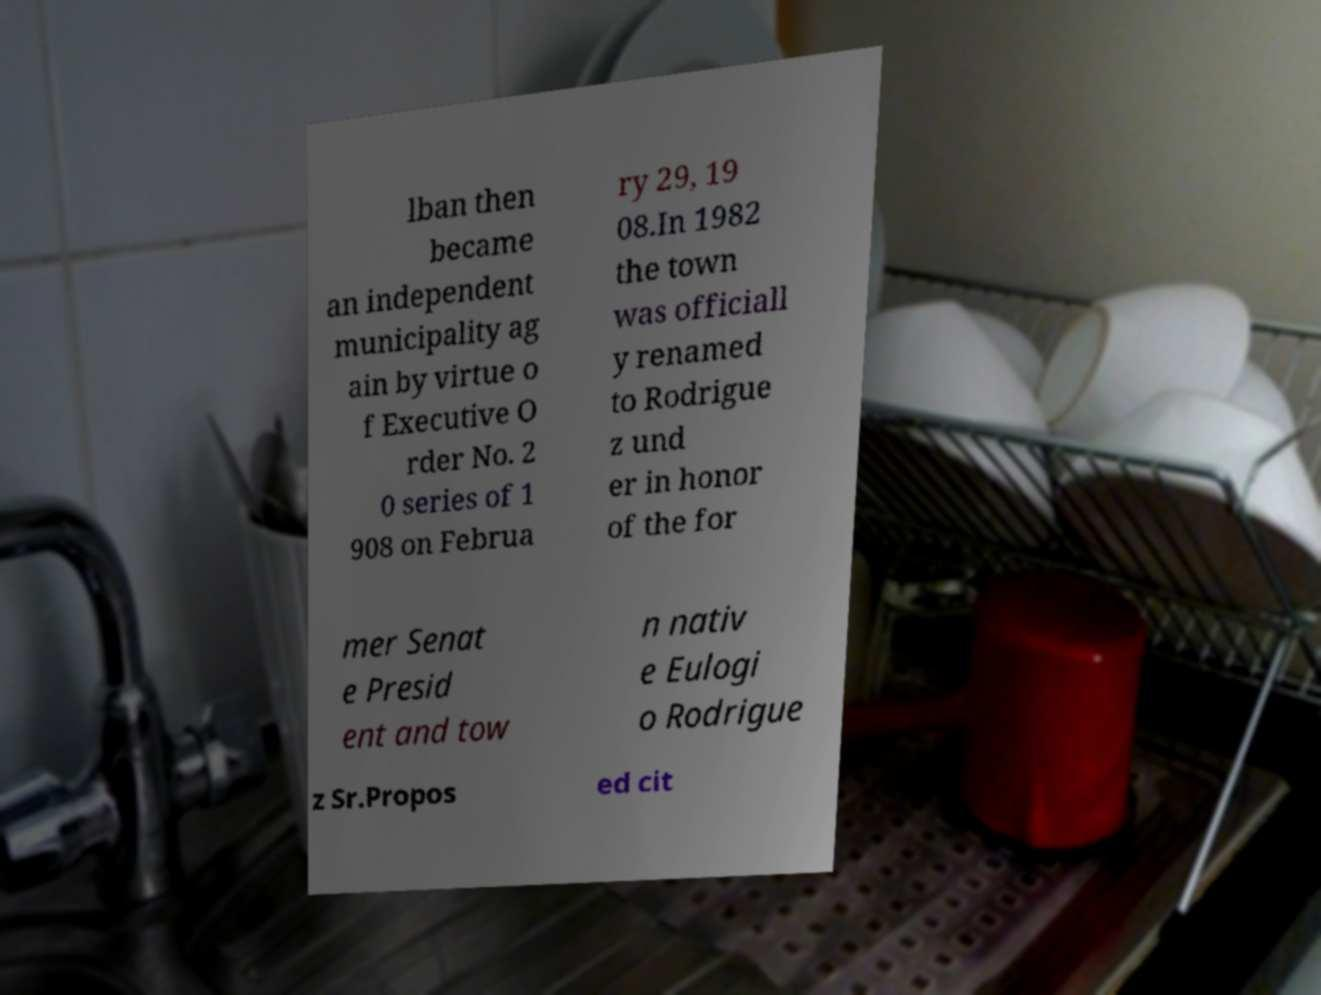Can you read and provide the text displayed in the image?This photo seems to have some interesting text. Can you extract and type it out for me? lban then became an independent municipality ag ain by virtue o f Executive O rder No. 2 0 series of 1 908 on Februa ry 29, 19 08.In 1982 the town was officiall y renamed to Rodrigue z und er in honor of the for mer Senat e Presid ent and tow n nativ e Eulogi o Rodrigue z Sr.Propos ed cit 